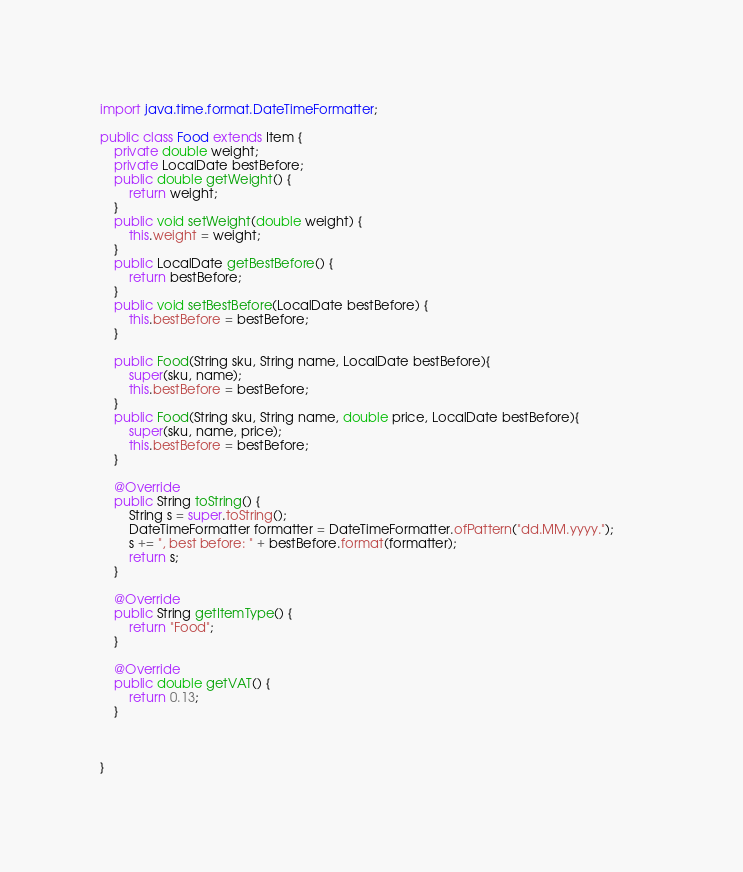<code> <loc_0><loc_0><loc_500><loc_500><_Java_>import java.time.format.DateTimeFormatter;

public class Food extends Item {
	private double weight;
	private LocalDate bestBefore;
	public double getWeight() {
		return weight;
	}
	public void setWeight(double weight) {
		this.weight = weight;
	}
	public LocalDate getBestBefore() {
		return bestBefore;
	}
	public void setBestBefore(LocalDate bestBefore) {
		this.bestBefore = bestBefore;
	}
		
	public Food(String sku, String name, LocalDate bestBefore){
		super(sku, name);		
		this.bestBefore = bestBefore;
	}	
	public Food(String sku, String name, double price, LocalDate bestBefore){
		super(sku, name, price);		
		this.bestBefore = bestBefore;
	}
	
	@Override
	public String toString() {
		String s = super.toString();
		DateTimeFormatter formatter = DateTimeFormatter.ofPattern("dd.MM.yyyy.");		
		s += ", best before: " + bestBefore.format(formatter);
		return s;
	}
	
	@Override
	public String getItemType() {
		return "Food";
	}
	
	@Override
	public double getVAT() {
		return 0.13;
	}

	
	
}
</code> 